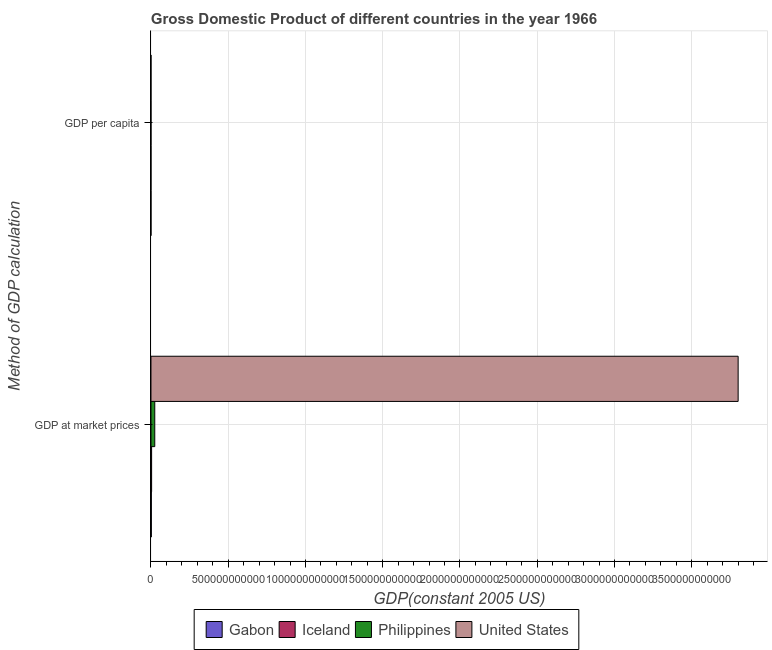What is the label of the 2nd group of bars from the top?
Offer a very short reply. GDP at market prices. What is the gdp at market prices in Iceland?
Make the answer very short. 4.24e+09. Across all countries, what is the maximum gdp at market prices?
Ensure brevity in your answer.  3.80e+12. Across all countries, what is the minimum gdp at market prices?
Offer a terse response. 2.35e+09. In which country was the gdp per capita maximum?
Provide a short and direct response. Iceland. In which country was the gdp at market prices minimum?
Provide a succinct answer. Gabon. What is the total gdp per capita in the graph?
Your answer should be very brief. 4.61e+04. What is the difference between the gdp per capita in United States and that in Iceland?
Make the answer very short. -2328.13. What is the difference between the gdp at market prices in United States and the gdp per capita in Iceland?
Your response must be concise. 3.80e+12. What is the average gdp at market prices per country?
Provide a short and direct response. 9.58e+11. What is the difference between the gdp per capita and gdp at market prices in Gabon?
Your answer should be compact. -2.35e+09. In how many countries, is the gdp per capita greater than 1100000000000 US$?
Provide a short and direct response. 0. What is the ratio of the gdp at market prices in Philippines to that in United States?
Your answer should be compact. 0.01. Is the gdp per capita in Iceland less than that in United States?
Provide a short and direct response. No. What does the 4th bar from the top in GDP per capita represents?
Your response must be concise. Gabon. Are all the bars in the graph horizontal?
Provide a succinct answer. Yes. What is the difference between two consecutive major ticks on the X-axis?
Offer a very short reply. 5.00e+11. Are the values on the major ticks of X-axis written in scientific E-notation?
Your answer should be compact. No. Does the graph contain any zero values?
Provide a succinct answer. No. Does the graph contain grids?
Keep it short and to the point. Yes. Where does the legend appear in the graph?
Offer a terse response. Bottom center. How many legend labels are there?
Make the answer very short. 4. How are the legend labels stacked?
Provide a short and direct response. Horizontal. What is the title of the graph?
Provide a succinct answer. Gross Domestic Product of different countries in the year 1966. Does "Malta" appear as one of the legend labels in the graph?
Make the answer very short. No. What is the label or title of the X-axis?
Your answer should be very brief. GDP(constant 2005 US). What is the label or title of the Y-axis?
Make the answer very short. Method of GDP calculation. What is the GDP(constant 2005 US) of Gabon in GDP at market prices?
Offer a terse response. 2.35e+09. What is the GDP(constant 2005 US) of Iceland in GDP at market prices?
Ensure brevity in your answer.  4.24e+09. What is the GDP(constant 2005 US) in Philippines in GDP at market prices?
Your answer should be very brief. 2.46e+1. What is the GDP(constant 2005 US) of United States in GDP at market prices?
Your answer should be compact. 3.80e+12. What is the GDP(constant 2005 US) in Gabon in GDP per capita?
Your response must be concise. 4337.52. What is the GDP(constant 2005 US) of Iceland in GDP per capita?
Keep it short and to the point. 2.17e+04. What is the GDP(constant 2005 US) in Philippines in GDP per capita?
Provide a short and direct response. 773.05. What is the GDP(constant 2005 US) in United States in GDP per capita?
Offer a terse response. 1.93e+04. Across all Method of GDP calculation, what is the maximum GDP(constant 2005 US) in Gabon?
Ensure brevity in your answer.  2.35e+09. Across all Method of GDP calculation, what is the maximum GDP(constant 2005 US) of Iceland?
Your answer should be very brief. 4.24e+09. Across all Method of GDP calculation, what is the maximum GDP(constant 2005 US) in Philippines?
Offer a very short reply. 2.46e+1. Across all Method of GDP calculation, what is the maximum GDP(constant 2005 US) in United States?
Make the answer very short. 3.80e+12. Across all Method of GDP calculation, what is the minimum GDP(constant 2005 US) in Gabon?
Your response must be concise. 4337.52. Across all Method of GDP calculation, what is the minimum GDP(constant 2005 US) in Iceland?
Make the answer very short. 2.17e+04. Across all Method of GDP calculation, what is the minimum GDP(constant 2005 US) in Philippines?
Provide a short and direct response. 773.05. Across all Method of GDP calculation, what is the minimum GDP(constant 2005 US) of United States?
Offer a terse response. 1.93e+04. What is the total GDP(constant 2005 US) of Gabon in the graph?
Make the answer very short. 2.35e+09. What is the total GDP(constant 2005 US) of Iceland in the graph?
Ensure brevity in your answer.  4.24e+09. What is the total GDP(constant 2005 US) in Philippines in the graph?
Offer a terse response. 2.46e+1. What is the total GDP(constant 2005 US) of United States in the graph?
Your answer should be compact. 3.80e+12. What is the difference between the GDP(constant 2005 US) of Gabon in GDP at market prices and that in GDP per capita?
Make the answer very short. 2.35e+09. What is the difference between the GDP(constant 2005 US) of Iceland in GDP at market prices and that in GDP per capita?
Provide a short and direct response. 4.24e+09. What is the difference between the GDP(constant 2005 US) in Philippines in GDP at market prices and that in GDP per capita?
Keep it short and to the point. 2.46e+1. What is the difference between the GDP(constant 2005 US) of United States in GDP at market prices and that in GDP per capita?
Your answer should be very brief. 3.80e+12. What is the difference between the GDP(constant 2005 US) in Gabon in GDP at market prices and the GDP(constant 2005 US) in Iceland in GDP per capita?
Provide a short and direct response. 2.35e+09. What is the difference between the GDP(constant 2005 US) of Gabon in GDP at market prices and the GDP(constant 2005 US) of Philippines in GDP per capita?
Your answer should be compact. 2.35e+09. What is the difference between the GDP(constant 2005 US) of Gabon in GDP at market prices and the GDP(constant 2005 US) of United States in GDP per capita?
Provide a succinct answer. 2.35e+09. What is the difference between the GDP(constant 2005 US) in Iceland in GDP at market prices and the GDP(constant 2005 US) in Philippines in GDP per capita?
Make the answer very short. 4.24e+09. What is the difference between the GDP(constant 2005 US) of Iceland in GDP at market prices and the GDP(constant 2005 US) of United States in GDP per capita?
Make the answer very short. 4.24e+09. What is the difference between the GDP(constant 2005 US) of Philippines in GDP at market prices and the GDP(constant 2005 US) of United States in GDP per capita?
Your answer should be very brief. 2.46e+1. What is the average GDP(constant 2005 US) of Gabon per Method of GDP calculation?
Provide a succinct answer. 1.18e+09. What is the average GDP(constant 2005 US) in Iceland per Method of GDP calculation?
Your response must be concise. 2.12e+09. What is the average GDP(constant 2005 US) of Philippines per Method of GDP calculation?
Make the answer very short. 1.23e+1. What is the average GDP(constant 2005 US) of United States per Method of GDP calculation?
Your response must be concise. 1.90e+12. What is the difference between the GDP(constant 2005 US) in Gabon and GDP(constant 2005 US) in Iceland in GDP at market prices?
Keep it short and to the point. -1.88e+09. What is the difference between the GDP(constant 2005 US) in Gabon and GDP(constant 2005 US) in Philippines in GDP at market prices?
Your response must be concise. -2.23e+1. What is the difference between the GDP(constant 2005 US) in Gabon and GDP(constant 2005 US) in United States in GDP at market prices?
Your answer should be very brief. -3.80e+12. What is the difference between the GDP(constant 2005 US) in Iceland and GDP(constant 2005 US) in Philippines in GDP at market prices?
Provide a succinct answer. -2.04e+1. What is the difference between the GDP(constant 2005 US) in Iceland and GDP(constant 2005 US) in United States in GDP at market prices?
Your response must be concise. -3.80e+12. What is the difference between the GDP(constant 2005 US) in Philippines and GDP(constant 2005 US) in United States in GDP at market prices?
Your answer should be compact. -3.78e+12. What is the difference between the GDP(constant 2005 US) of Gabon and GDP(constant 2005 US) of Iceland in GDP per capita?
Your answer should be very brief. -1.73e+04. What is the difference between the GDP(constant 2005 US) of Gabon and GDP(constant 2005 US) of Philippines in GDP per capita?
Provide a short and direct response. 3564.47. What is the difference between the GDP(constant 2005 US) of Gabon and GDP(constant 2005 US) of United States in GDP per capita?
Offer a terse response. -1.50e+04. What is the difference between the GDP(constant 2005 US) of Iceland and GDP(constant 2005 US) of Philippines in GDP per capita?
Provide a succinct answer. 2.09e+04. What is the difference between the GDP(constant 2005 US) in Iceland and GDP(constant 2005 US) in United States in GDP per capita?
Provide a short and direct response. 2328.13. What is the difference between the GDP(constant 2005 US) of Philippines and GDP(constant 2005 US) of United States in GDP per capita?
Your answer should be very brief. -1.86e+04. What is the ratio of the GDP(constant 2005 US) in Gabon in GDP at market prices to that in GDP per capita?
Offer a very short reply. 5.43e+05. What is the ratio of the GDP(constant 2005 US) in Iceland in GDP at market prices to that in GDP per capita?
Make the answer very short. 1.96e+05. What is the ratio of the GDP(constant 2005 US) in Philippines in GDP at market prices to that in GDP per capita?
Your answer should be very brief. 3.19e+07. What is the ratio of the GDP(constant 2005 US) of United States in GDP at market prices to that in GDP per capita?
Provide a succinct answer. 1.97e+08. What is the difference between the highest and the second highest GDP(constant 2005 US) in Gabon?
Provide a short and direct response. 2.35e+09. What is the difference between the highest and the second highest GDP(constant 2005 US) in Iceland?
Your answer should be compact. 4.24e+09. What is the difference between the highest and the second highest GDP(constant 2005 US) in Philippines?
Provide a short and direct response. 2.46e+1. What is the difference between the highest and the second highest GDP(constant 2005 US) of United States?
Provide a short and direct response. 3.80e+12. What is the difference between the highest and the lowest GDP(constant 2005 US) of Gabon?
Offer a terse response. 2.35e+09. What is the difference between the highest and the lowest GDP(constant 2005 US) of Iceland?
Provide a succinct answer. 4.24e+09. What is the difference between the highest and the lowest GDP(constant 2005 US) in Philippines?
Provide a short and direct response. 2.46e+1. What is the difference between the highest and the lowest GDP(constant 2005 US) of United States?
Offer a terse response. 3.80e+12. 